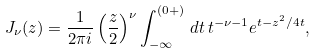Convert formula to latex. <formula><loc_0><loc_0><loc_500><loc_500>J _ { \nu } ( z ) = \frac { 1 } { 2 \pi i } \left ( \frac { z } { 2 } \right ) ^ { \nu } \int _ { - \infty } ^ { ( 0 + ) } \, d t \, t ^ { - \nu - 1 } e ^ { t - z ^ { 2 } / 4 t } ,</formula> 